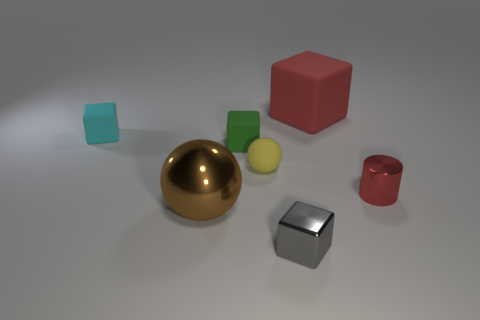Subtract all rubber cubes. How many cubes are left? 1 Add 1 small metal things. How many objects exist? 8 Subtract all red blocks. How many blocks are left? 3 Subtract all blue blocks. Subtract all yellow cylinders. How many blocks are left? 4 Subtract all cylinders. How many objects are left? 6 Add 6 metallic balls. How many metallic balls are left? 7 Add 7 blue metallic blocks. How many blue metallic blocks exist? 7 Subtract 0 green spheres. How many objects are left? 7 Subtract all small red metal cylinders. Subtract all cyan things. How many objects are left? 5 